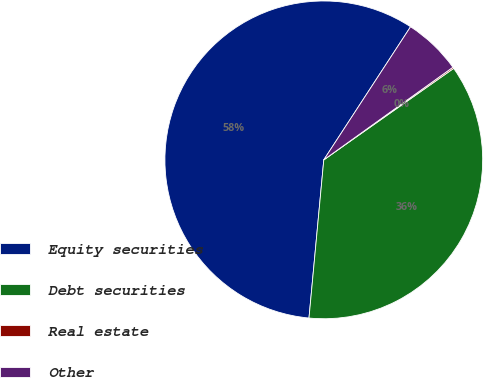Convert chart to OTSL. <chart><loc_0><loc_0><loc_500><loc_500><pie_chart><fcel>Equity securities<fcel>Debt securities<fcel>Real estate<fcel>Other<nl><fcel>57.71%<fcel>36.25%<fcel>0.14%<fcel>5.9%<nl></chart> 